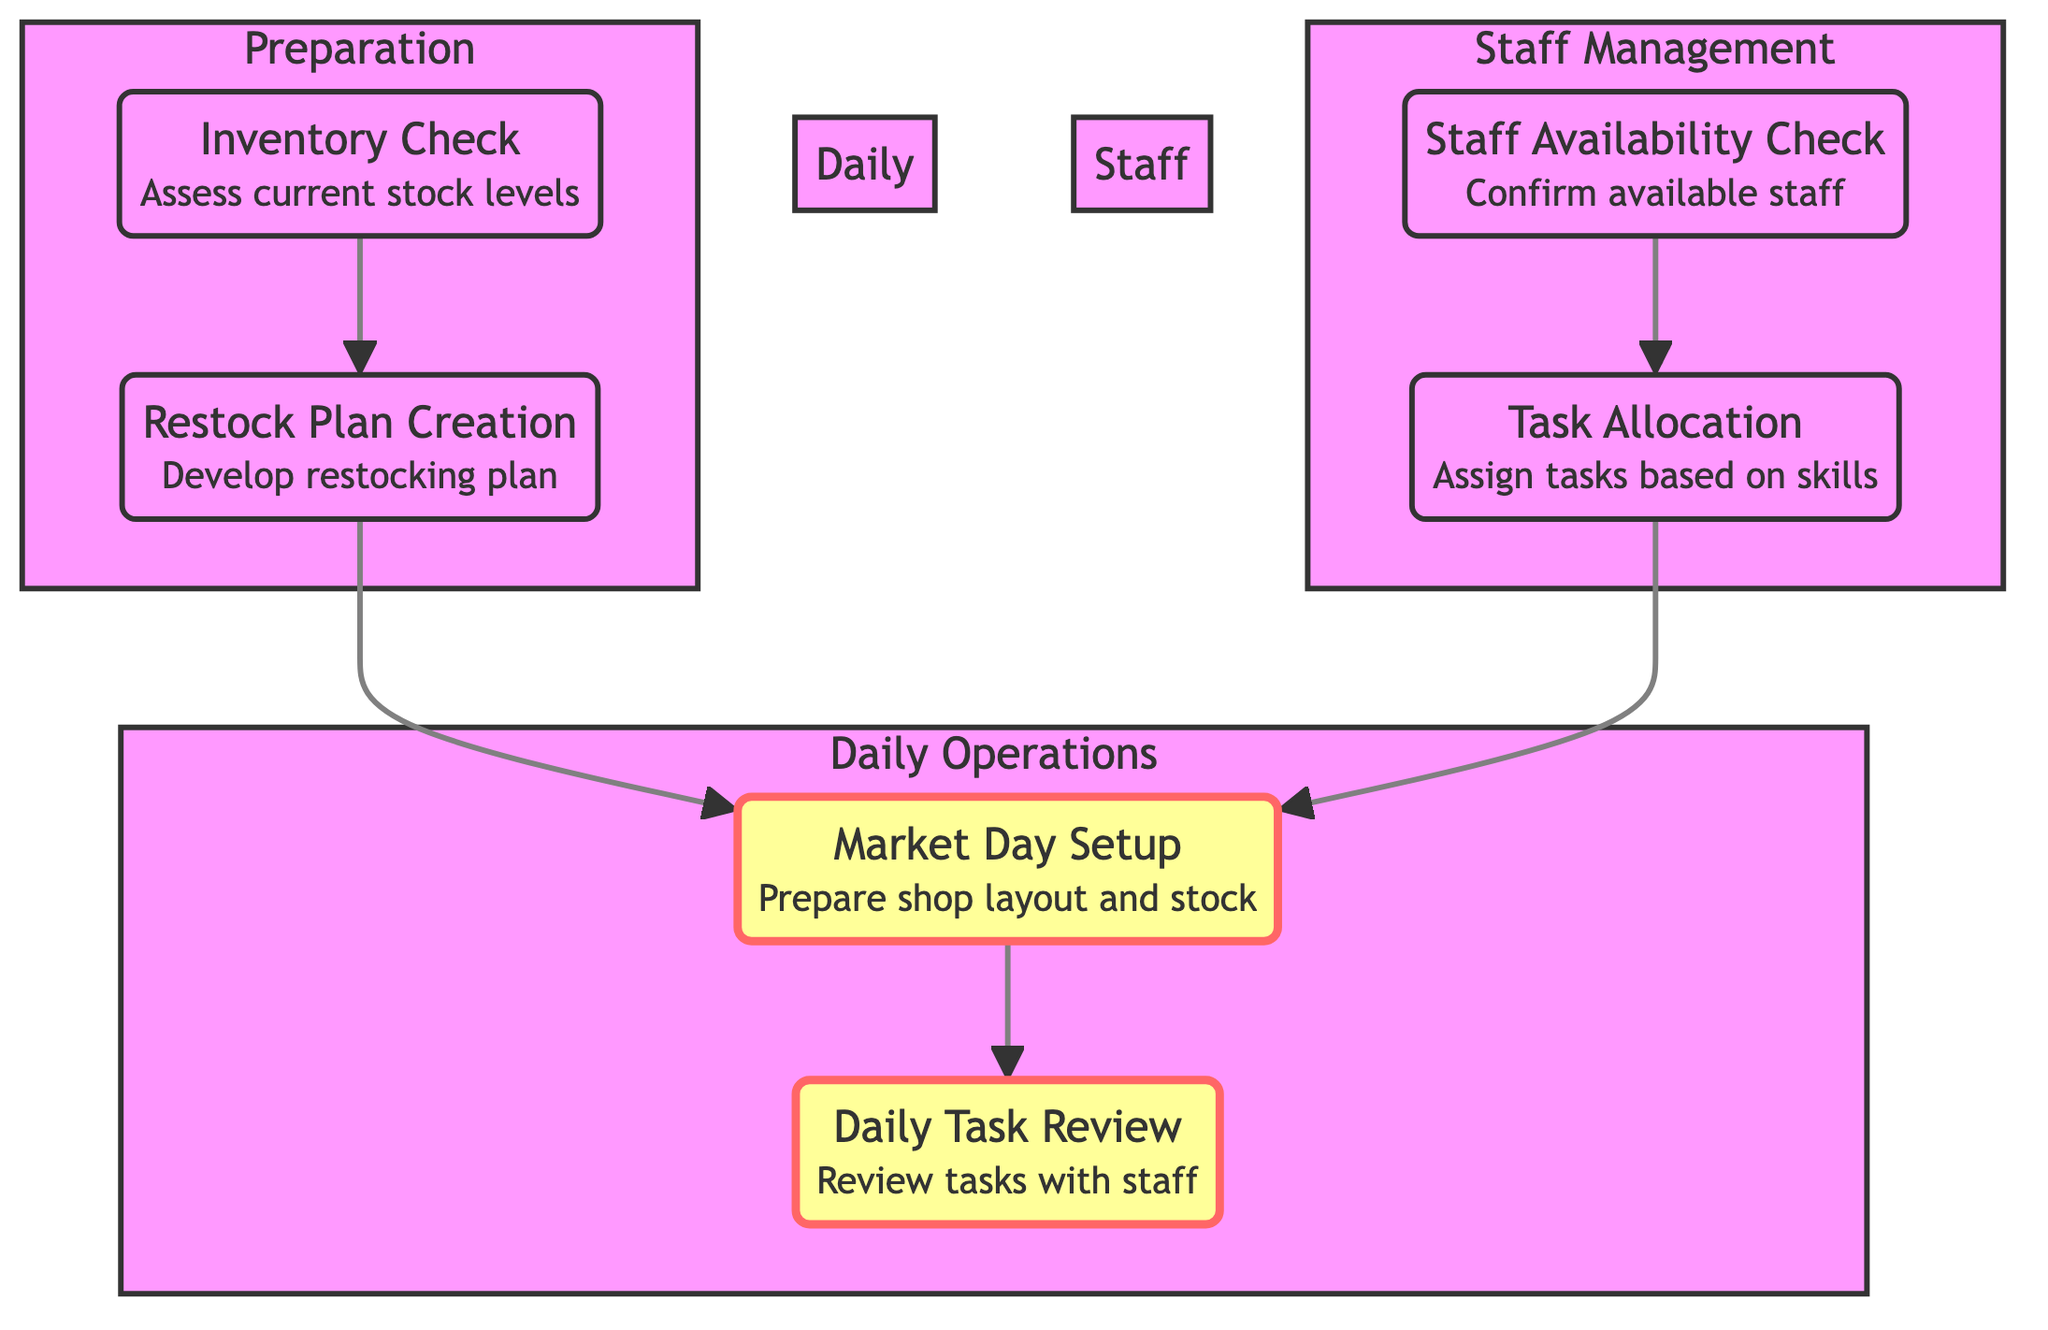What is the first step in the preparation phase? The first step listed in the preparation phase is the "Inventory Check," which assesses the current stock levels.
Answer: Inventory Check How many main sections are in the flow chart? The flow chart has three main sections: Daily Operations, Preparation, and Staff Management.
Answer: Three What is the last step in the Daily Operations section? The last step in the Daily Operations section is "Daily Task Review," which involves reviewing the day's tasks with staff.
Answer: Daily Task Review Which node connects to both "Restock Plan Creation" and "Market Day Setup"? The "Restock Plan Creation" node connects to "Market Day Setup," indicating that the results of the restocking plan are used in setting up for market days.
Answer: Restock Plan Creation What is the relationship between "Staff Availability Check" and "Task Allocation"? "Staff Availability Check" leads to "Task Allocation," meaning that the availability of staff informs how tasks are assigned.
Answer: Leads to What is the purpose of "Task Allocation"? The purpose of "Task Allocation" is to assign tasks to staff based on their skills and availability.
Answer: Assign tasks How many edges are in the diagram? The diagram contains five edges, which connect the different nodes in the flow of the staff scheduling and task allocation process.
Answer: Five Which section includes "Market Day Setup"? "Market Day Setup" is included in the Daily Operations section, which is focused on preparing for market activity.
Answer: Daily Operations What follows after "Market Day Setup"? After "Market Day Setup," the next step is the "Daily Task Review," involving discussion with the staff about the day's tasks.
Answer: Daily Task Review 